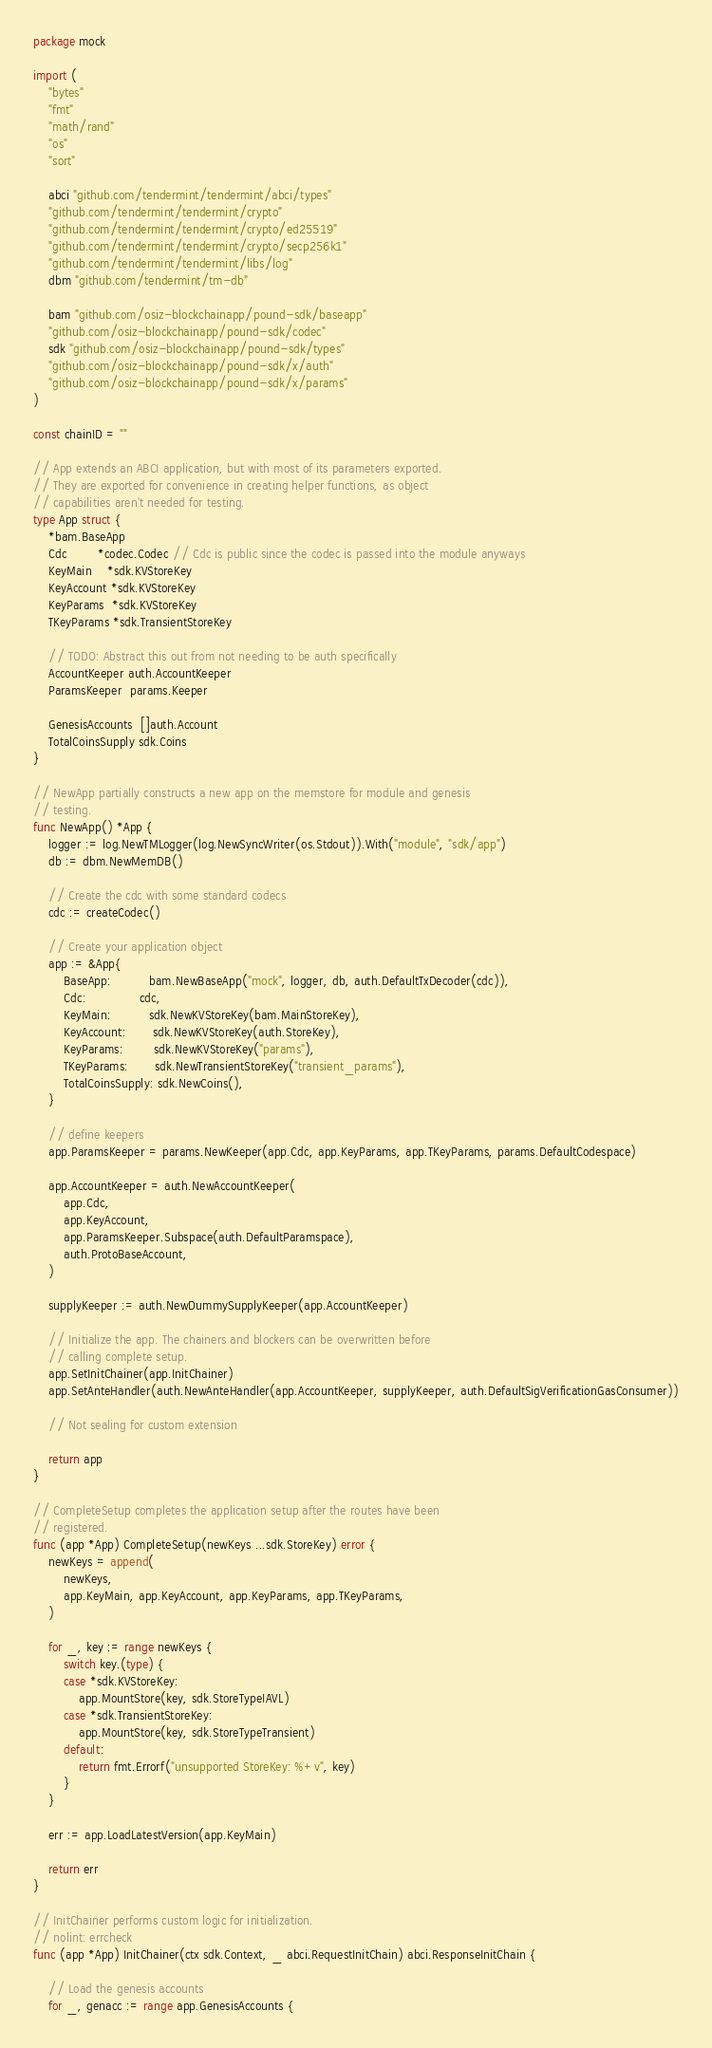<code> <loc_0><loc_0><loc_500><loc_500><_Go_>package mock

import (
	"bytes"
	"fmt"
	"math/rand"
	"os"
	"sort"

	abci "github.com/tendermint/tendermint/abci/types"
	"github.com/tendermint/tendermint/crypto"
	"github.com/tendermint/tendermint/crypto/ed25519"
	"github.com/tendermint/tendermint/crypto/secp256k1"
	"github.com/tendermint/tendermint/libs/log"
	dbm "github.com/tendermint/tm-db"

	bam "github.com/osiz-blockchainapp/pound-sdk/baseapp"
	"github.com/osiz-blockchainapp/pound-sdk/codec"
	sdk "github.com/osiz-blockchainapp/pound-sdk/types"
	"github.com/osiz-blockchainapp/pound-sdk/x/auth"
	"github.com/osiz-blockchainapp/pound-sdk/x/params"
)

const chainID = ""

// App extends an ABCI application, but with most of its parameters exported.
// They are exported for convenience in creating helper functions, as object
// capabilities aren't needed for testing.
type App struct {
	*bam.BaseApp
	Cdc        *codec.Codec // Cdc is public since the codec is passed into the module anyways
	KeyMain    *sdk.KVStoreKey
	KeyAccount *sdk.KVStoreKey
	KeyParams  *sdk.KVStoreKey
	TKeyParams *sdk.TransientStoreKey

	// TODO: Abstract this out from not needing to be auth specifically
	AccountKeeper auth.AccountKeeper
	ParamsKeeper  params.Keeper

	GenesisAccounts  []auth.Account
	TotalCoinsSupply sdk.Coins
}

// NewApp partially constructs a new app on the memstore for module and genesis
// testing.
func NewApp() *App {
	logger := log.NewTMLogger(log.NewSyncWriter(os.Stdout)).With("module", "sdk/app")
	db := dbm.NewMemDB()

	// Create the cdc with some standard codecs
	cdc := createCodec()

	// Create your application object
	app := &App{
		BaseApp:          bam.NewBaseApp("mock", logger, db, auth.DefaultTxDecoder(cdc)),
		Cdc:              cdc,
		KeyMain:          sdk.NewKVStoreKey(bam.MainStoreKey),
		KeyAccount:       sdk.NewKVStoreKey(auth.StoreKey),
		KeyParams:        sdk.NewKVStoreKey("params"),
		TKeyParams:       sdk.NewTransientStoreKey("transient_params"),
		TotalCoinsSupply: sdk.NewCoins(),
	}

	// define keepers
	app.ParamsKeeper = params.NewKeeper(app.Cdc, app.KeyParams, app.TKeyParams, params.DefaultCodespace)

	app.AccountKeeper = auth.NewAccountKeeper(
		app.Cdc,
		app.KeyAccount,
		app.ParamsKeeper.Subspace(auth.DefaultParamspace),
		auth.ProtoBaseAccount,
	)

	supplyKeeper := auth.NewDummySupplyKeeper(app.AccountKeeper)

	// Initialize the app. The chainers and blockers can be overwritten before
	// calling complete setup.
	app.SetInitChainer(app.InitChainer)
	app.SetAnteHandler(auth.NewAnteHandler(app.AccountKeeper, supplyKeeper, auth.DefaultSigVerificationGasConsumer))

	// Not sealing for custom extension

	return app
}

// CompleteSetup completes the application setup after the routes have been
// registered.
func (app *App) CompleteSetup(newKeys ...sdk.StoreKey) error {
	newKeys = append(
		newKeys,
		app.KeyMain, app.KeyAccount, app.KeyParams, app.TKeyParams,
	)

	for _, key := range newKeys {
		switch key.(type) {
		case *sdk.KVStoreKey:
			app.MountStore(key, sdk.StoreTypeIAVL)
		case *sdk.TransientStoreKey:
			app.MountStore(key, sdk.StoreTypeTransient)
		default:
			return fmt.Errorf("unsupported StoreKey: %+v", key)
		}
	}

	err := app.LoadLatestVersion(app.KeyMain)

	return err
}

// InitChainer performs custom logic for initialization.
// nolint: errcheck
func (app *App) InitChainer(ctx sdk.Context, _ abci.RequestInitChain) abci.ResponseInitChain {

	// Load the genesis accounts
	for _, genacc := range app.GenesisAccounts {</code> 